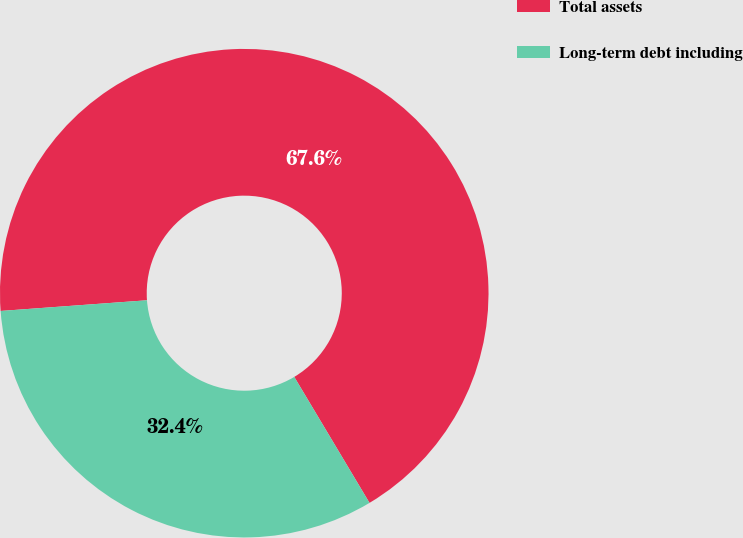Convert chart to OTSL. <chart><loc_0><loc_0><loc_500><loc_500><pie_chart><fcel>Total assets<fcel>Long-term debt including<nl><fcel>67.59%<fcel>32.41%<nl></chart> 